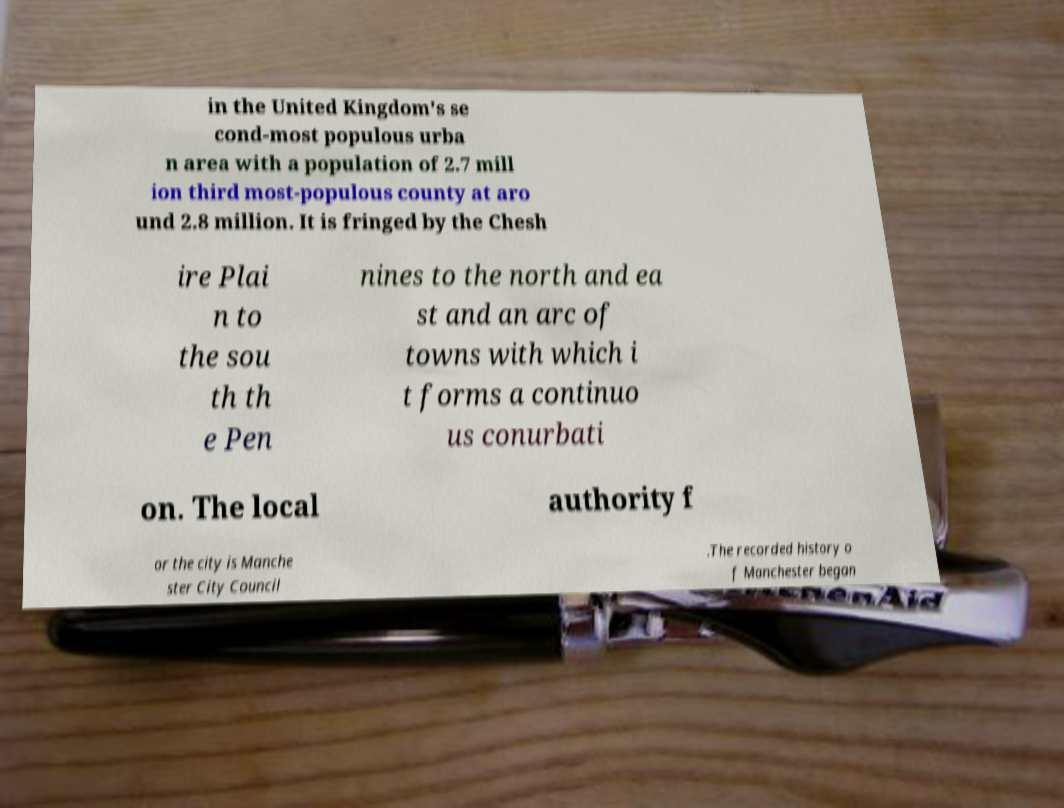For documentation purposes, I need the text within this image transcribed. Could you provide that? in the United Kingdom's se cond-most populous urba n area with a population of 2.7 mill ion third most-populous county at aro und 2.8 million. It is fringed by the Chesh ire Plai n to the sou th th e Pen nines to the north and ea st and an arc of towns with which i t forms a continuo us conurbati on. The local authority f or the city is Manche ster City Council .The recorded history o f Manchester began 